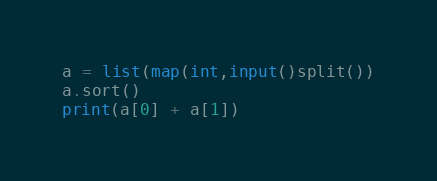Convert code to text. <code><loc_0><loc_0><loc_500><loc_500><_Python_>a = list(map(int,input()split())
a.sort()
print(a[0] + a[1])
</code> 